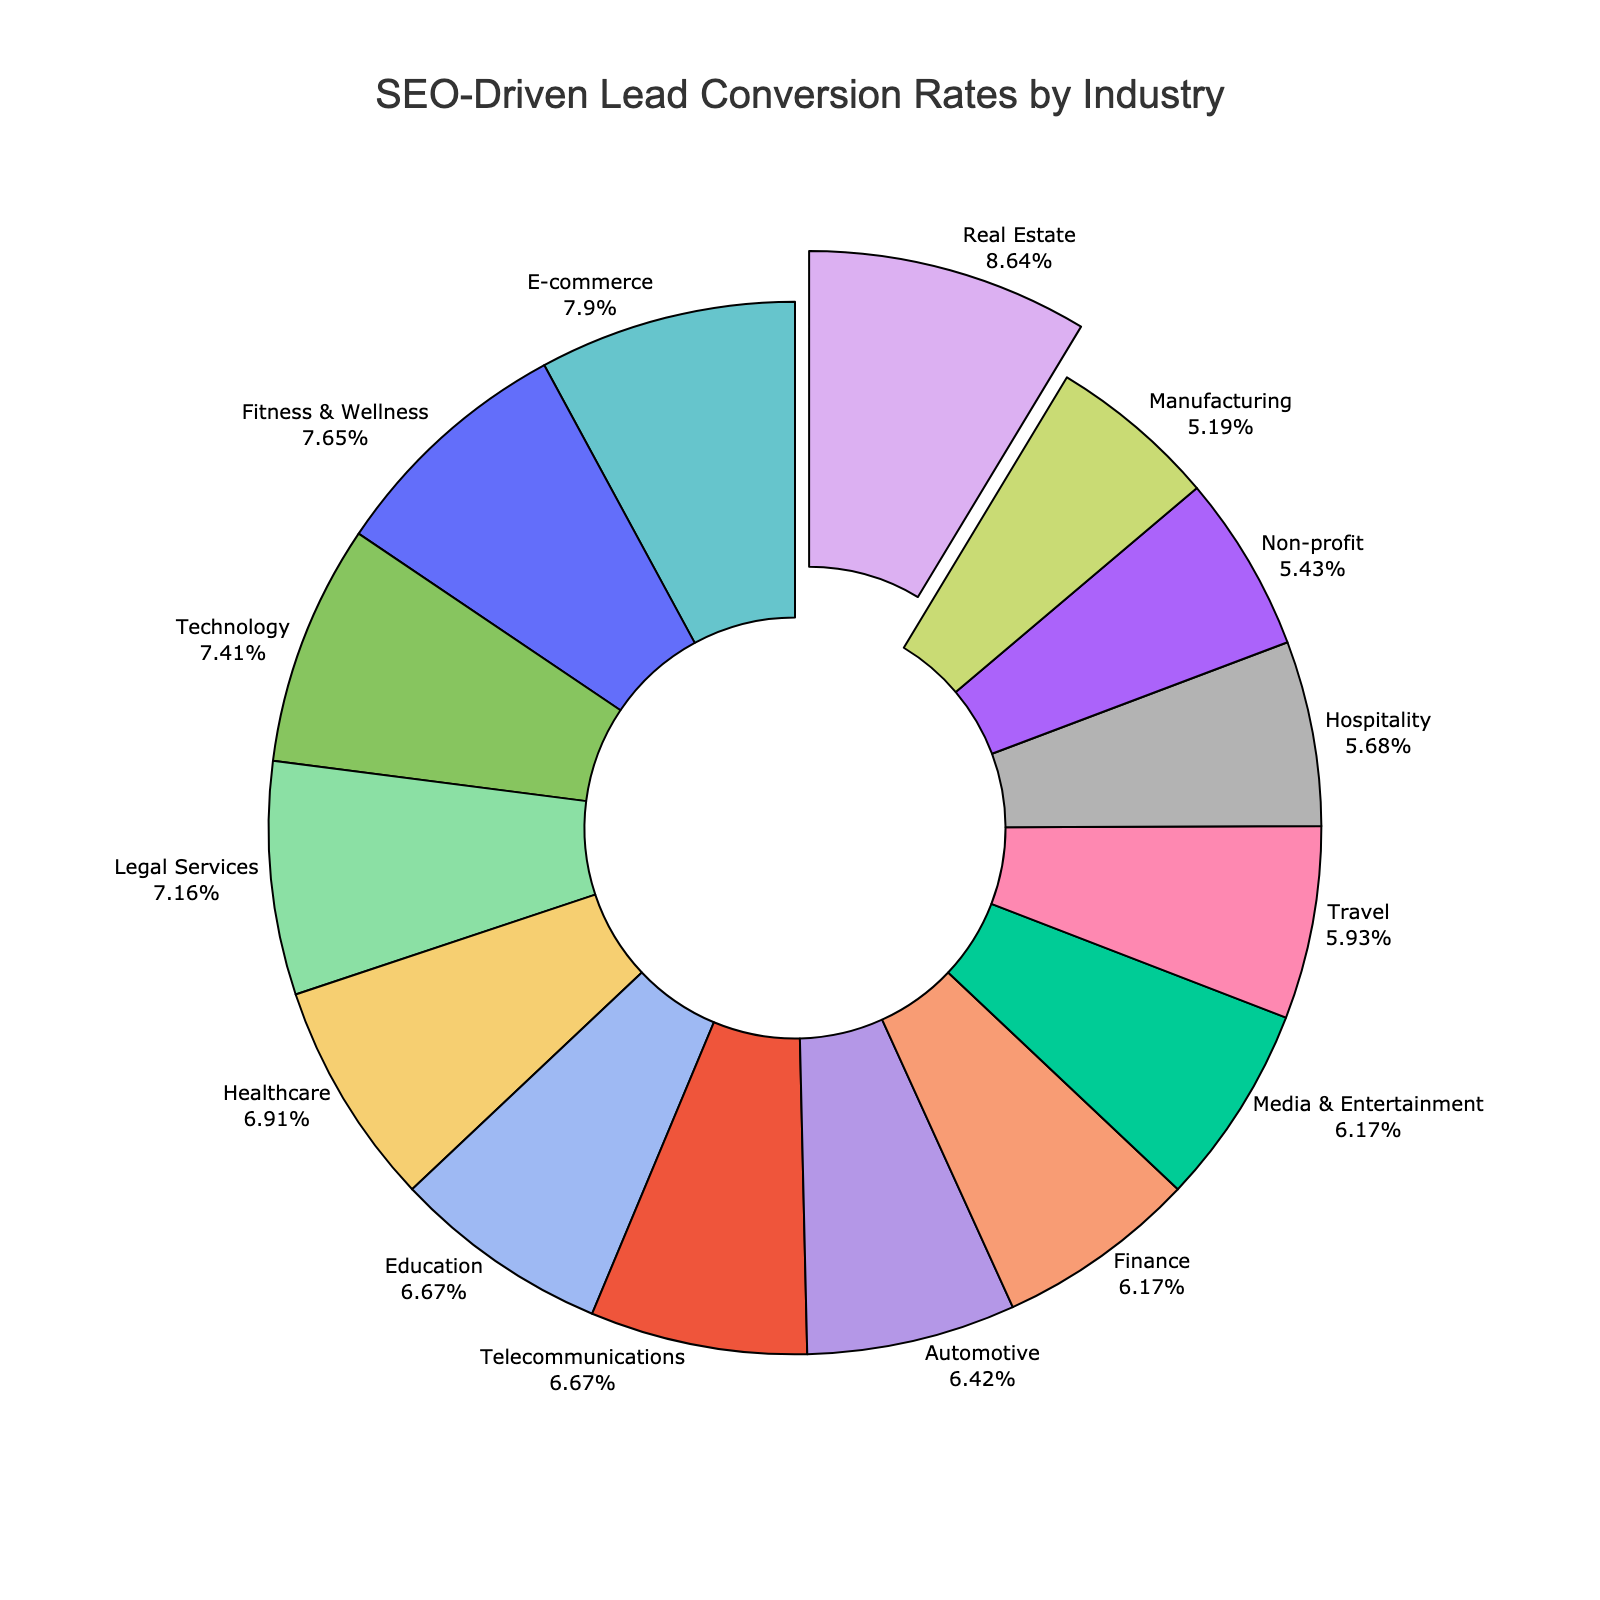What's the industry with the highest SEO-driven lead conversion rate? The pie chart highlights the industry with the highest conversion rate by pulling the segment away from the center slightly. The "Real Estate" industry is noticeably pulled away and labeled with the highest percentage at 3.5%.
Answer: Real Estate Which industry has the lowest SEO-driven lead conversion rate? By scanning the conversion rates on the pie chart, the "Manufacturing" industry displays the lowest conversion rate at 2.1%.
Answer: Manufacturing How does the conversion rate of the Education industry compare to the Media & Entertainment industry? The Education industry has a conversion rate of 2.7%, while the Media & Entertainment industry has a conversion rate of 2.5%. Comparing these values, the Education industry has a higher conversion rate.
Answer: Education has a higher rate What is the combined SEO-driven lead conversion rate of the Healthcare, Automotive, and Hospitality industries? First, extract the conversion rates of Healthcare (2.8%), Automotive (2.6%), and Hospitality (2.3%). Adding these together yields 2.8% + 2.6% + 2.3% = 7.7%.
Answer: 7.7% Are there any industries with the same SEO-driven lead conversion rate, and if so, which ones? By checking the percentages on the pie chart, both the Education and Telecommunications industries have the same conversion rate of 2.7%.
Answer: Education and Telecommunications Which industry has a higher SEO-driven lead conversion rate: Technology or Fitness & Wellness? The Technology industry has a conversion rate of 3.0%, whereas the Fitness & Wellness industry has a conversion rate of 3.1%. Therefore, the Fitness & Wellness industry has a higher conversion rate.
Answer: Fitness & Wellness What percentage of the total does the E-commerce industry represent in the pie chart? The E-commerce industry's conversion rate is 3.2%. Since the question is about the percentage it represents within the pie chart, and given that each slice's percentage represents its proportion of the total, the slice's labeled percentage is directly given as 3.2%.
Answer: 3.2% If we grouped the industries into those with conversion rates above 3.0% and those below 3.0%, how many industries fall into each category? Industries with rates above 3.0% (E-commerce, Real Estate, Technology, Fitness & Wellness) total 4. The remaining industries (Healthcare, Finance, Education, Travel, Manufacturing, Legal Services, Automotive, Hospitality, Telecommunications, Media & Entertainment, Non-profit) total 11.
Answer: Above 3.0%: 4, Below 3.0%: 11 